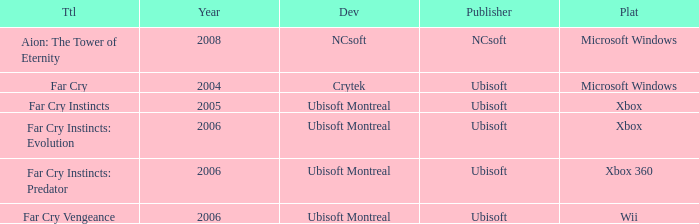What xbox title was released before 2006? Far Cry Instincts. 